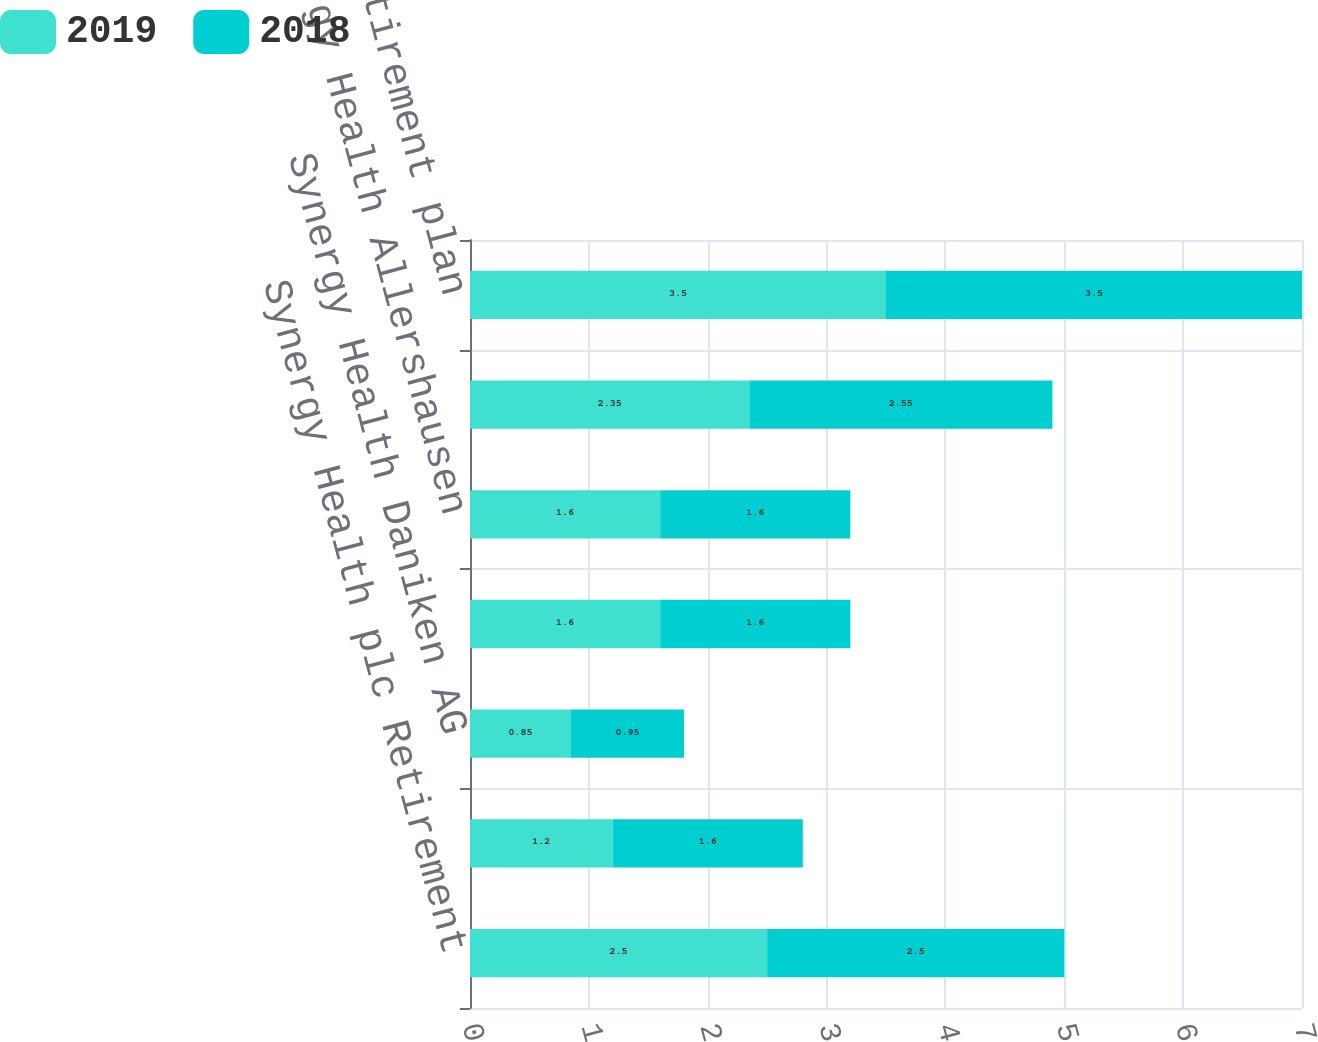Convert chart to OTSL. <chart><loc_0><loc_0><loc_500><loc_500><stacked_bar_chart><ecel><fcel>Synergy Health plc Retirement<fcel>Isotron BV Pension Plan<fcel>Synergy Health Daniken AG<fcel>Synergy Health Radeberg<fcel>Synergy Health Allershausen<fcel>Harwell Dosimeters Ltd<fcel>Other post-retirement plan<nl><fcel>2019<fcel>2.5<fcel>1.2<fcel>0.85<fcel>1.6<fcel>1.6<fcel>2.35<fcel>3.5<nl><fcel>2018<fcel>2.5<fcel>1.6<fcel>0.95<fcel>1.6<fcel>1.6<fcel>2.55<fcel>3.5<nl></chart> 